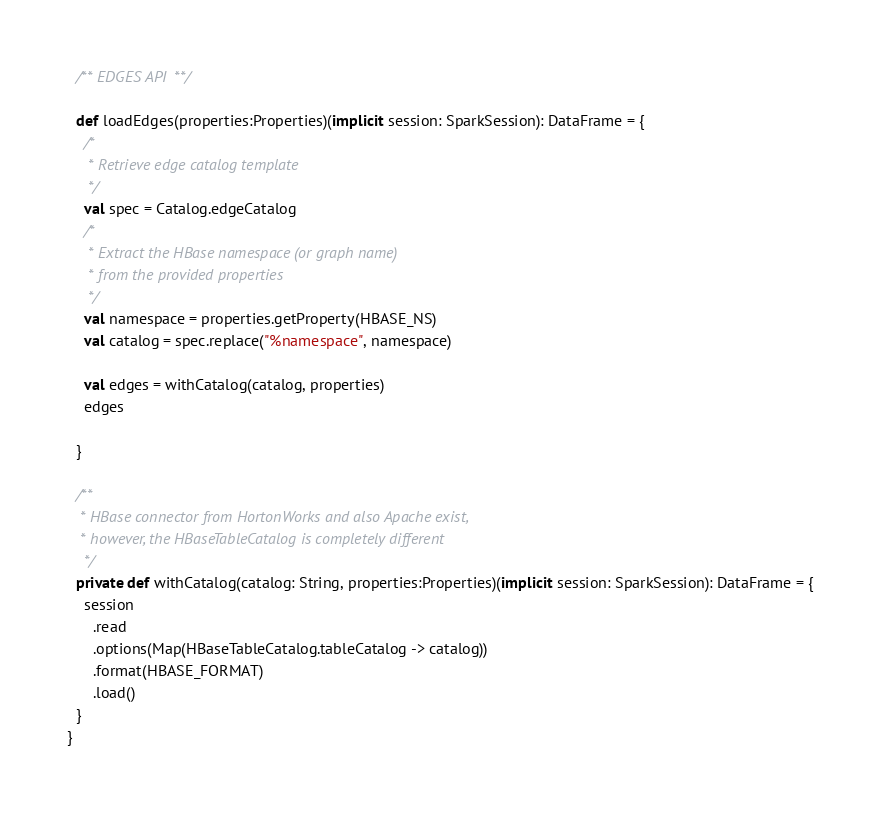<code> <loc_0><loc_0><loc_500><loc_500><_Scala_>
  /** EDGES API **/

  def loadEdges(properties:Properties)(implicit session: SparkSession): DataFrame = {
    /*
     * Retrieve edge catalog template
     */
    val spec = Catalog.edgeCatalog
    /*
     * Extract the HBase namespace (or graph name)
     * from the provided properties
     */
    val namespace = properties.getProperty(HBASE_NS)
    val catalog = spec.replace("%namespace", namespace)

    val edges = withCatalog(catalog, properties)
    edges

  }

  /**
   * HBase connector from HortonWorks and also Apache exist,
   * however, the HBaseTableCatalog is completely different
    */
  private def withCatalog(catalog: String, properties:Properties)(implicit session: SparkSession): DataFrame = {
    session
      .read
      .options(Map(HBaseTableCatalog.tableCatalog -> catalog))
      .format(HBASE_FORMAT)
      .load()
  }
}
</code> 